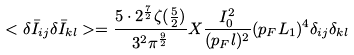Convert formula to latex. <formula><loc_0><loc_0><loc_500><loc_500>< \delta \bar { I } _ { i j } \delta \bar { I } _ { k l } > = \frac { 5 \cdot 2 ^ { \frac { 7 } { 2 } } \zeta ( \frac { 5 } { 2 } ) } { 3 ^ { 2 } \pi ^ { \frac { 9 } { 2 } } } X \frac { I _ { 0 } ^ { 2 } } { ( p _ { F } l ) ^ { 2 } } ( p _ { F } L _ { 1 } ) ^ { 4 } \delta _ { i j } \delta _ { k l }</formula> 